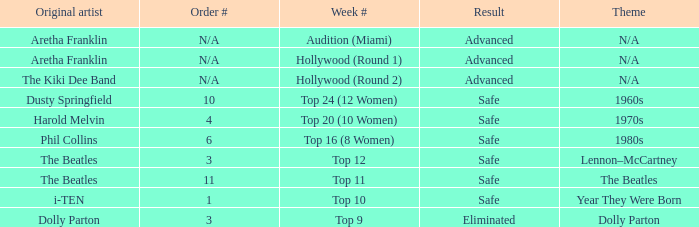What is the week number that has Dolly Parton as the theme? Top 9. 